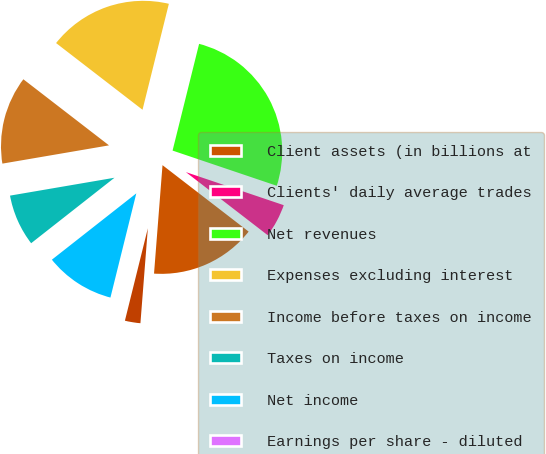<chart> <loc_0><loc_0><loc_500><loc_500><pie_chart><fcel>Client assets (in billions at<fcel>Clients' daily average trades<fcel>Net revenues<fcel>Expenses excluding interest<fcel>Income before taxes on income<fcel>Taxes on income<fcel>Net income<fcel>Earnings per share - diluted<fcel>Net revenue per average<nl><fcel>15.79%<fcel>5.27%<fcel>26.31%<fcel>18.42%<fcel>13.16%<fcel>7.9%<fcel>10.53%<fcel>0.0%<fcel>2.63%<nl></chart> 